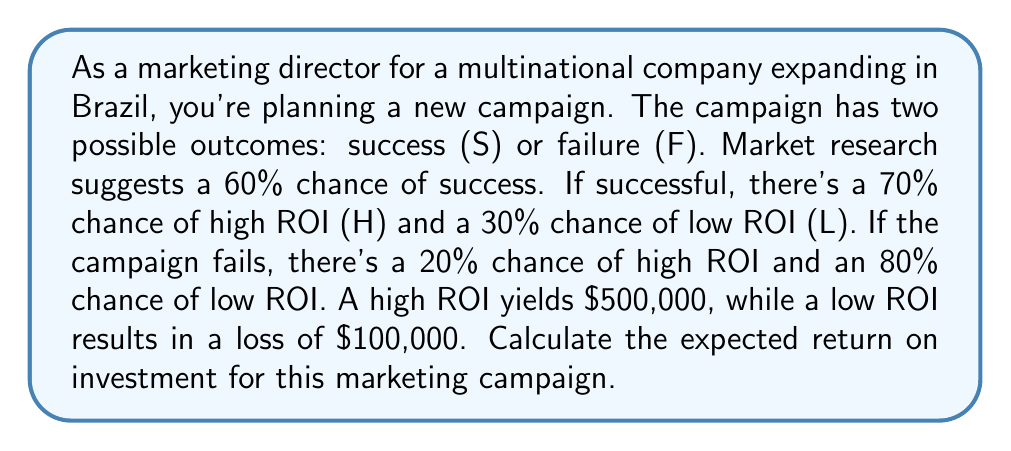Can you answer this question? Let's approach this step-by-step using a decision tree and conditional probability:

1) First, let's define our probabilities:
   P(S) = 0.6 (success)
   P(F) = 0.4 (failure)
   P(H|S) = 0.7 (high ROI given success)
   P(L|S) = 0.3 (low ROI given success)
   P(H|F) = 0.2 (high ROI given failure)
   P(L|F) = 0.8 (low ROI given failure)

2) Now, let's calculate the probability of each outcome:
   P(S and H) = P(S) * P(H|S) = 0.6 * 0.7 = 0.42
   P(S and L) = P(S) * P(L|S) = 0.6 * 0.3 = 0.18
   P(F and H) = P(F) * P(H|F) = 0.4 * 0.2 = 0.08
   P(F and L) = P(F) * P(L|F) = 0.4 * 0.8 = 0.32

3) The expected value of each outcome:
   E(S and H) = 0.42 * $500,000 = $210,000
   E(S and L) = 0.18 * (-$100,000) = -$18,000
   E(F and H) = 0.08 * $500,000 = $40,000
   E(F and L) = 0.32 * (-$100,000) = -$32,000

4) The total expected return is the sum of these values:
   E(Total) = $210,000 + (-$18,000) + $40,000 + (-$32,000) = $200,000

Therefore, the expected return on investment for this marketing campaign is $200,000.
Answer: $200,000 